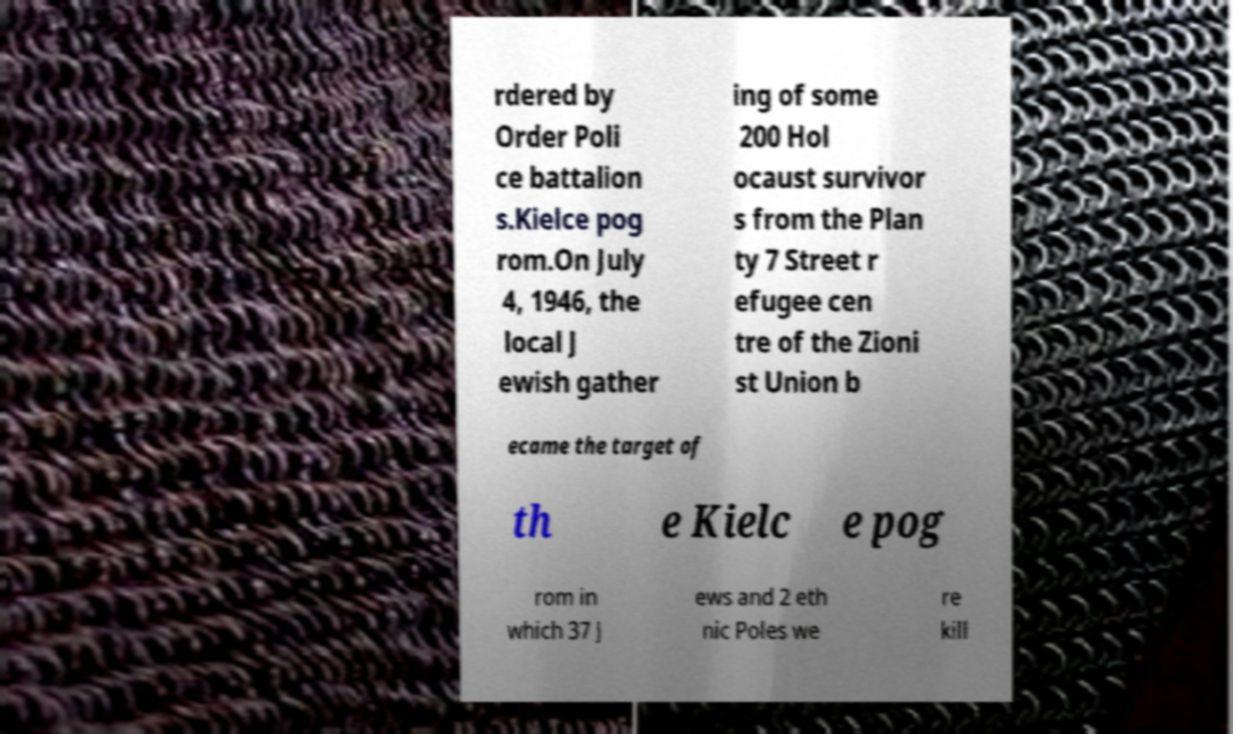For documentation purposes, I need the text within this image transcribed. Could you provide that? rdered by Order Poli ce battalion s.Kielce pog rom.On July 4, 1946, the local J ewish gather ing of some 200 Hol ocaust survivor s from the Plan ty 7 Street r efugee cen tre of the Zioni st Union b ecame the target of th e Kielc e pog rom in which 37 J ews and 2 eth nic Poles we re kill 